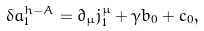<formula> <loc_0><loc_0><loc_500><loc_500>\delta a _ { 1 } ^ { h - A } = \partial _ { \mu } j _ { 1 } ^ { \mu } + \gamma b _ { 0 } + c _ { 0 } ,</formula> 